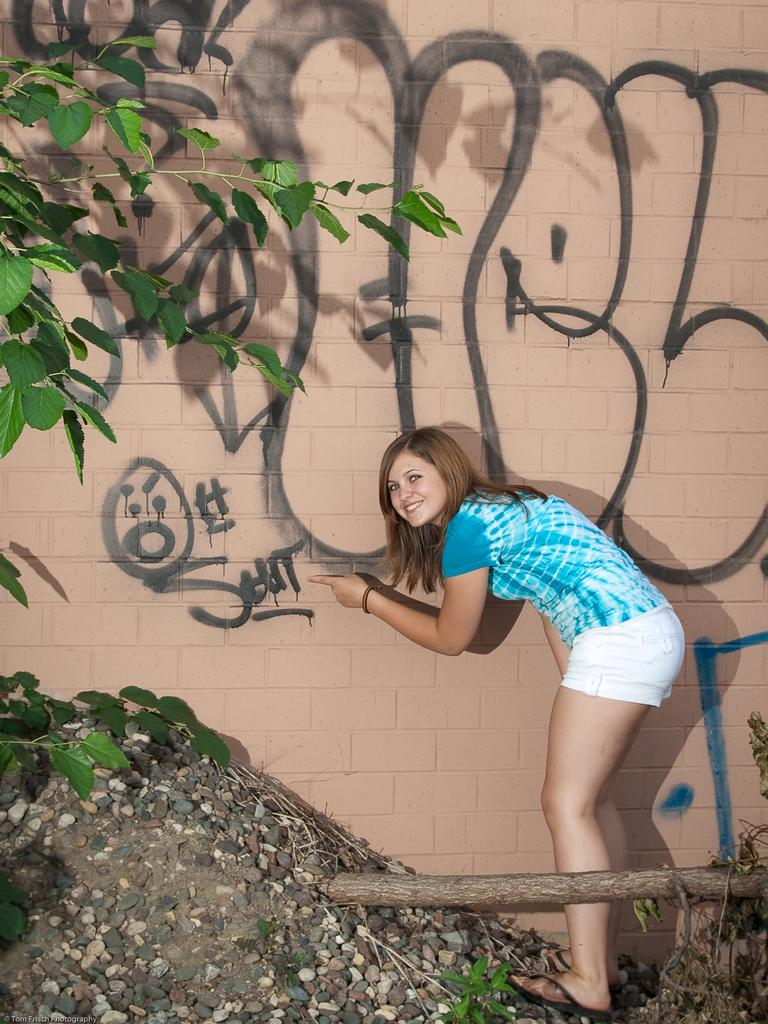What type of natural elements can be seen in the image? There are leaves in the image. What type of inorganic elements can be seen in the image? There are stones in the image. What is located at the bottom of the image? There are other unspecified things at the bottom of the image. What is written or depicted on a wall in the image? There is text visible on a wall in the image. What else can be seen on the wall? There are a few unspecified things on the wall. Who is present in the image? There is a person standing in the image. What is the person's facial expression? The person is smiling. What flavor of ice cream is the person holding in the image? There is no ice cream present in the image; the person is not holding any food item. How many walls are visible in the image? The image only shows one wall, as it is mentioned that there is text visible on a wall. 